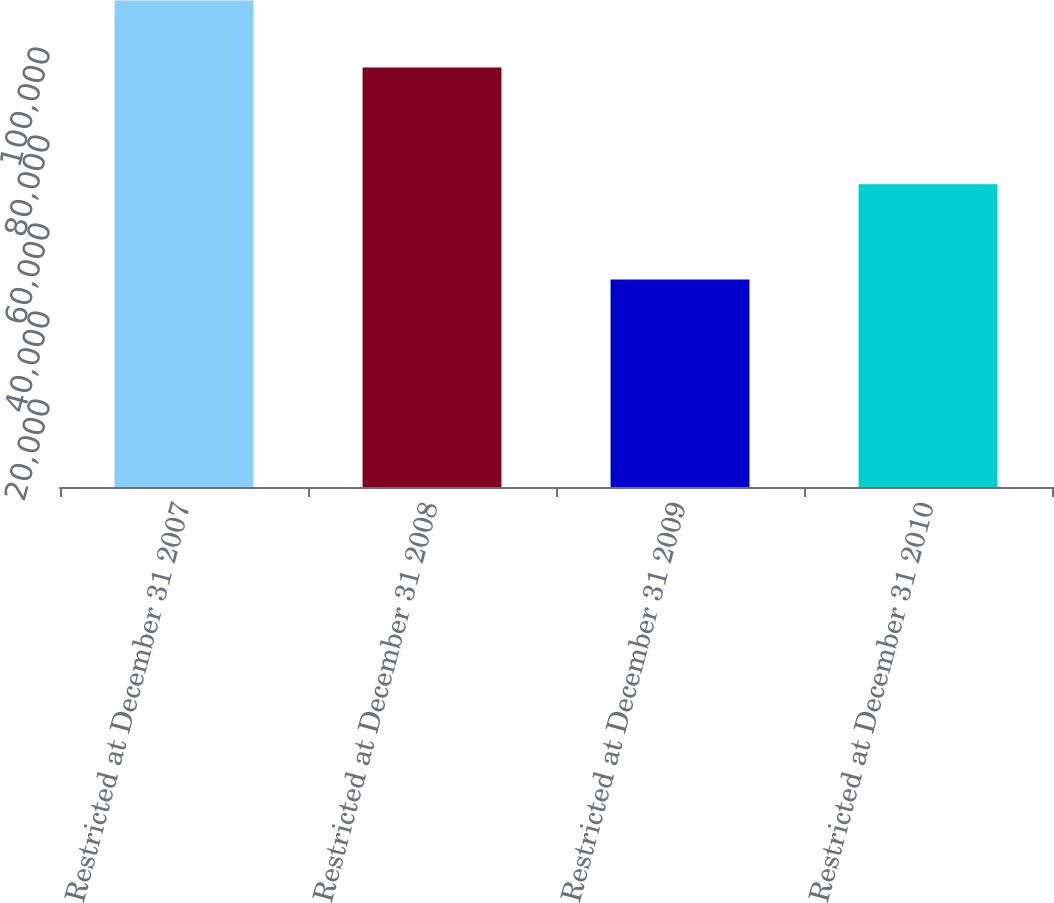Convert chart. <chart><loc_0><loc_0><loc_500><loc_500><bar_chart><fcel>Restricted at December 31 2007<fcel>Restricted at December 31 2008<fcel>Restricted at December 31 2009<fcel>Restricted at December 31 2010<nl><fcel>110593<fcel>95338<fcel>47160<fcel>68791<nl></chart> 